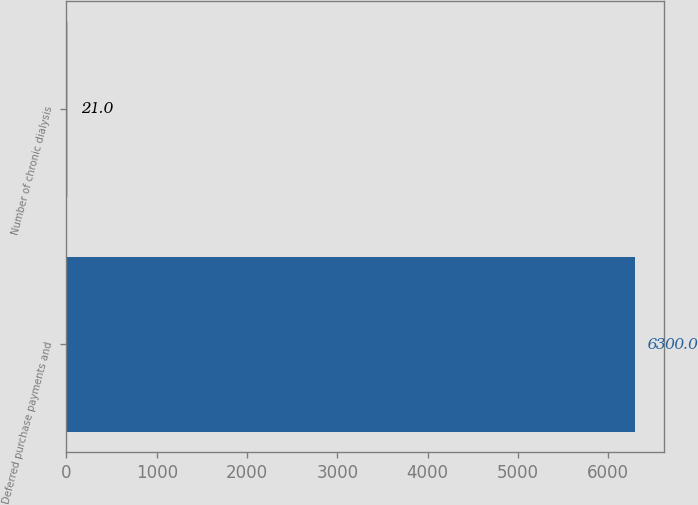Convert chart to OTSL. <chart><loc_0><loc_0><loc_500><loc_500><bar_chart><fcel>Deferred purchase payments and<fcel>Number of chronic dialysis<nl><fcel>6300<fcel>21<nl></chart> 